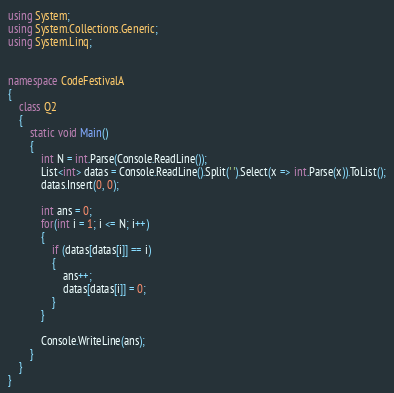Convert code to text. <code><loc_0><loc_0><loc_500><loc_500><_C#_>using System;
using System.Collections.Generic;
using System.Linq;


namespace CodeFestivalA
{
	class Q2
	{
		static void Main()
		{
			int N = int.Parse(Console.ReadLine());
			List<int> datas = Console.ReadLine().Split(' ').Select(x => int.Parse(x)).ToList();
			datas.Insert(0, 0);

			int ans = 0;
			for(int i = 1; i <= N; i++)
			{
				if (datas[datas[i]] == i)
				{
					ans++;
					datas[datas[i]] = 0;
				}
			}

			Console.WriteLine(ans);
		}
	}
}
</code> 